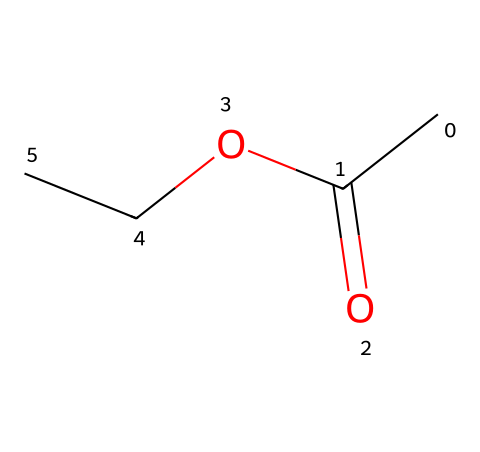What is the molecular formula of ethyl acetate? The SMILES representation shows two carbon atoms from the ethyl group (CC) and two from the acetate part (C(=O)O), leading to a molecular formula of C4H8O2.
Answer: C4H8O2 How many oxygen atoms are present in ethyl acetate? In the SMILES, there are two oxygen atoms indicated by the "O" symbols in the structure.
Answer: 2 What type of functional group is found in ethyl acetate? The SMILES shows a carbonyl group (C=O) and an alkoxy group (OCC), which together indicate the presence of an ester functional group.
Answer: ester What is the total number of carbon atoms in ethyl acetate? In the representation, there are four carbon atoms: two from the ethyl (CC) and two in the acetate part (C(=O)O), making the total four.
Answer: 4 What kind of reaction is typically used to synthesize esters like ethyl acetate? Esters are commonly formed through a condensation reaction known as esterification, involving an alcohol and a carboxylic acid.
Answer: esterification How many single and double bonds are present in ethyl acetate? In the given structure, there are four single bonds (between C, C, O) and one double bond (C=O), determining the total as five bonds.
Answer: 4 single, 1 double 